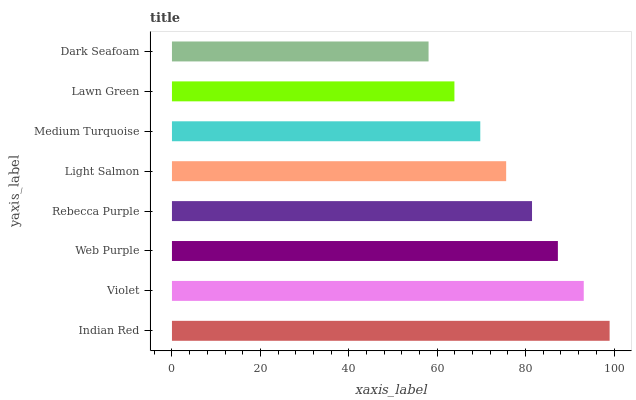Is Dark Seafoam the minimum?
Answer yes or no. Yes. Is Indian Red the maximum?
Answer yes or no. Yes. Is Violet the minimum?
Answer yes or no. No. Is Violet the maximum?
Answer yes or no. No. Is Indian Red greater than Violet?
Answer yes or no. Yes. Is Violet less than Indian Red?
Answer yes or no. Yes. Is Violet greater than Indian Red?
Answer yes or no. No. Is Indian Red less than Violet?
Answer yes or no. No. Is Rebecca Purple the high median?
Answer yes or no. Yes. Is Light Salmon the low median?
Answer yes or no. Yes. Is Medium Turquoise the high median?
Answer yes or no. No. Is Rebecca Purple the low median?
Answer yes or no. No. 